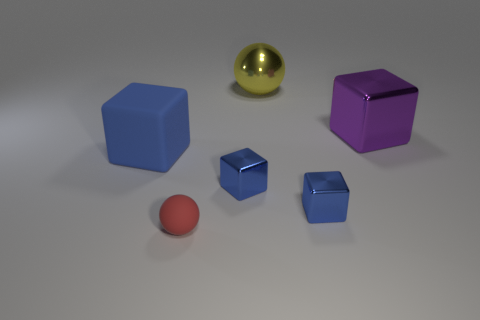Subtract all yellow cylinders. How many blue cubes are left? 3 Subtract 1 cubes. How many cubes are left? 3 Add 3 big blue cubes. How many objects exist? 9 Subtract all balls. How many objects are left? 4 Subtract 0 yellow cubes. How many objects are left? 6 Subtract all red things. Subtract all blue shiny cubes. How many objects are left? 3 Add 1 small blue objects. How many small blue objects are left? 3 Add 3 red spheres. How many red spheres exist? 4 